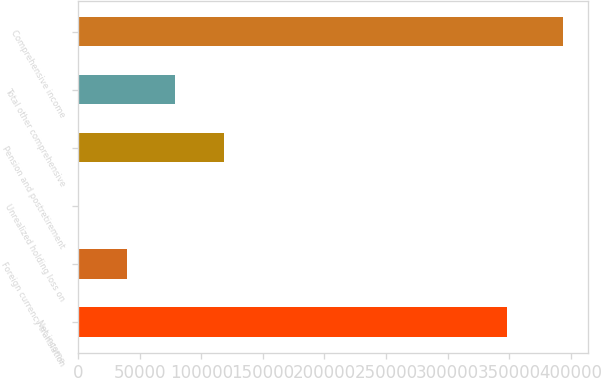<chart> <loc_0><loc_0><loc_500><loc_500><bar_chart><fcel>Net income<fcel>Foreign currency translation<fcel>Unrealized holding loss on<fcel>Pension and postretirement<fcel>Total other comprehensive<fcel>Comprehensive income<nl><fcel>348380<fcel>39537.5<fcel>147<fcel>118318<fcel>78928<fcel>394052<nl></chart> 